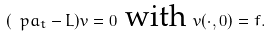Convert formula to latex. <formula><loc_0><loc_0><loc_500><loc_500>( \ p a _ { t } - L ) v = 0 \text { with } v ( \cdot , 0 ) = f .</formula> 